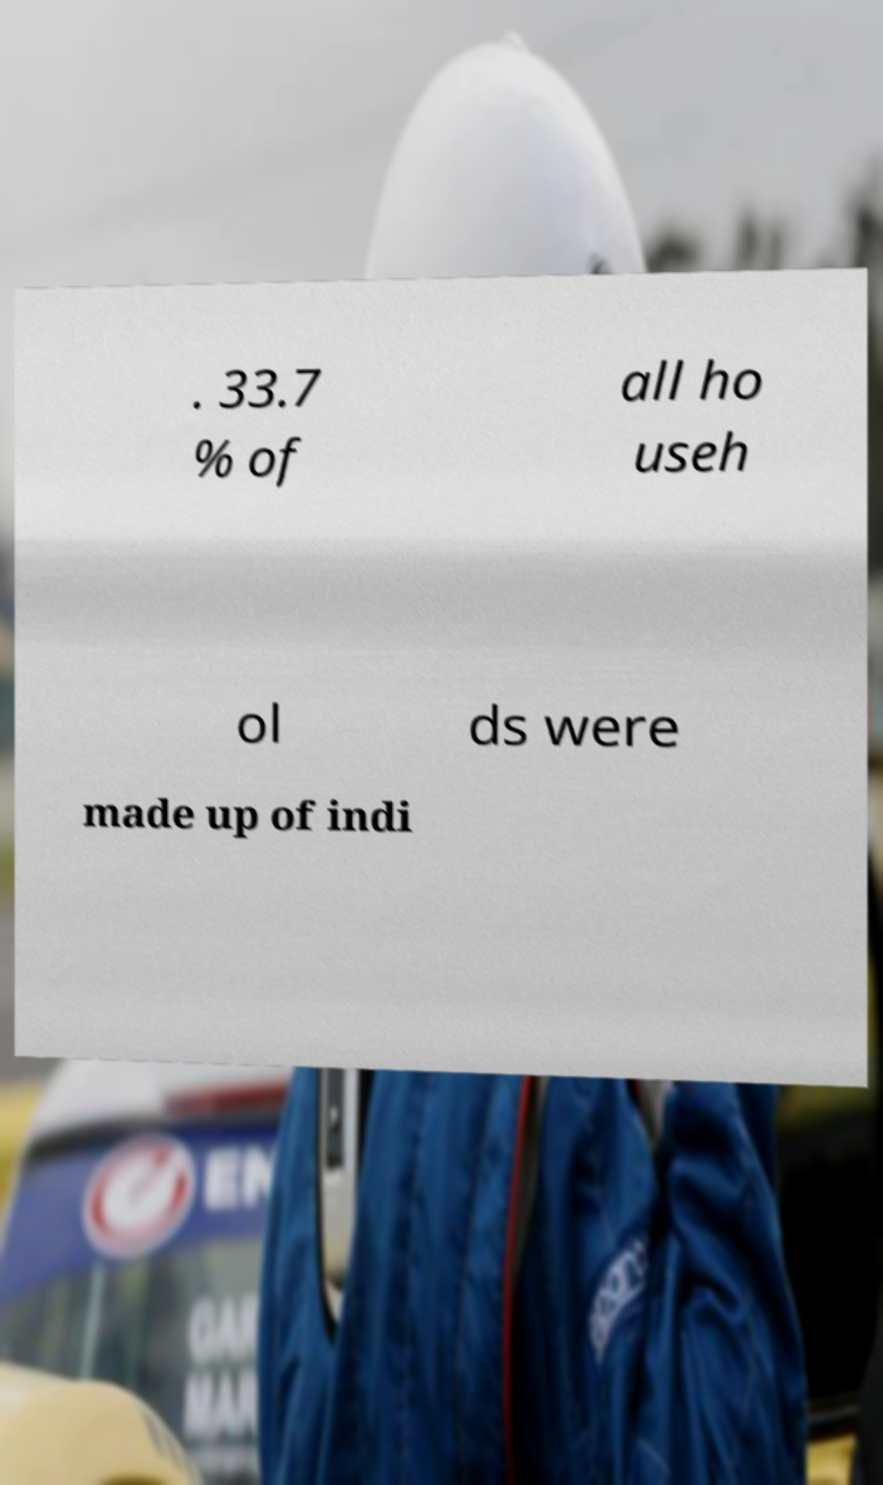Please identify and transcribe the text found in this image. . 33.7 % of all ho useh ol ds were made up of indi 